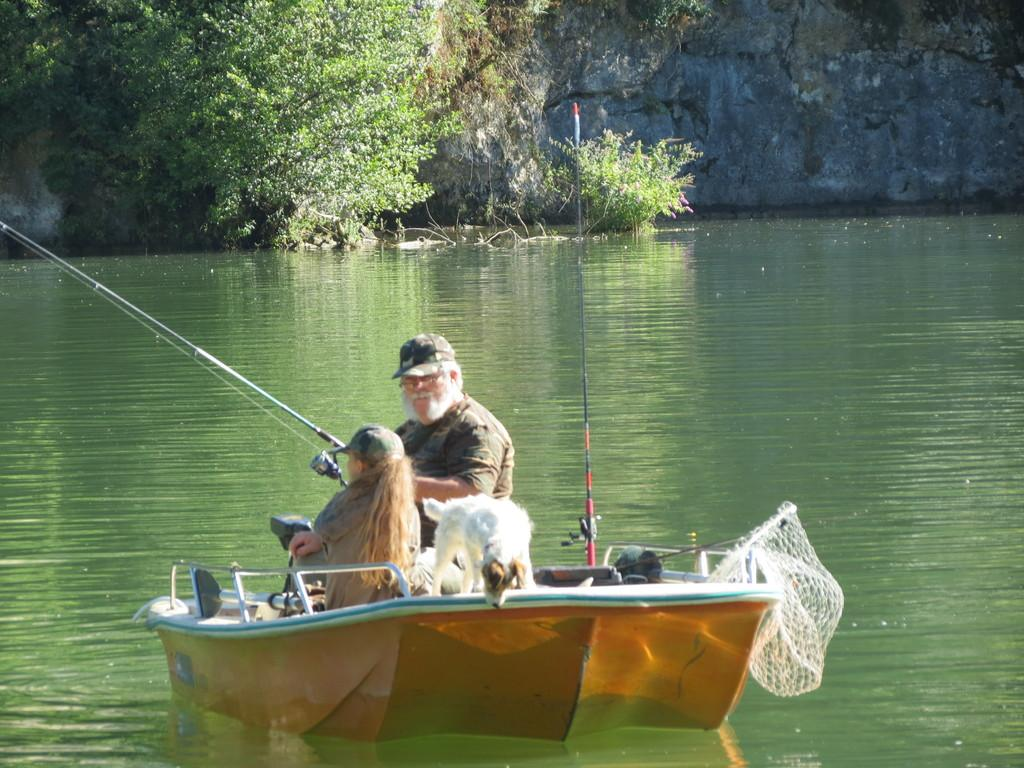Who is present in the image? There is a man, a girl, and a dog in the image. What are they doing in the image? They are in a boat. What is the man holding in the image? The man is holding a fishing rod. What is the boat floating on? The boat is floating on water. What can be seen in the background of the image? There are trees visible in the image, and the scene appears to be on a hill. What type of locket is the girl wearing in the image? There is no locket visible on the girl in the image. Is there a dock near the boat in the image? There is no dock present in the image; the boat is floating on water. 